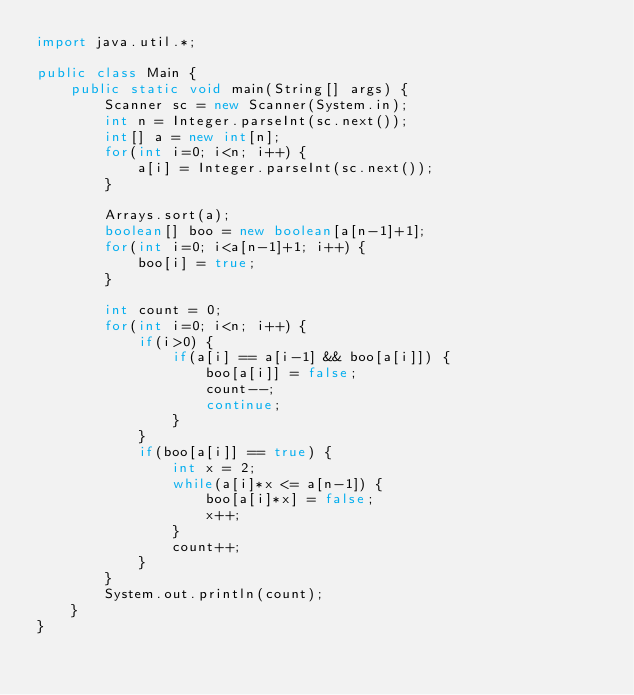<code> <loc_0><loc_0><loc_500><loc_500><_Java_>import java.util.*;
 
public class Main {
    public static void main(String[] args) {
        Scanner sc = new Scanner(System.in);
        int n = Integer.parseInt(sc.next());
        int[] a = new int[n];
        for(int i=0; i<n; i++) {
            a[i] = Integer.parseInt(sc.next());
        }
        
        Arrays.sort(a);
        boolean[] boo = new boolean[a[n-1]+1];
        for(int i=0; i<a[n-1]+1; i++) {
            boo[i] = true;
        }
        
        int count = 0;
        for(int i=0; i<n; i++) {
            if(i>0) {
                if(a[i] == a[i-1] && boo[a[i]]) {
                    boo[a[i]] = false;
                    count--;
                    continue;
                }
            }
            if(boo[a[i]] == true) {
                int x = 2;
                while(a[i]*x <= a[n-1]) {
                    boo[a[i]*x] = false;
                    x++;
                }
                count++;
            } 
        }
        System.out.println(count);
    }
}</code> 